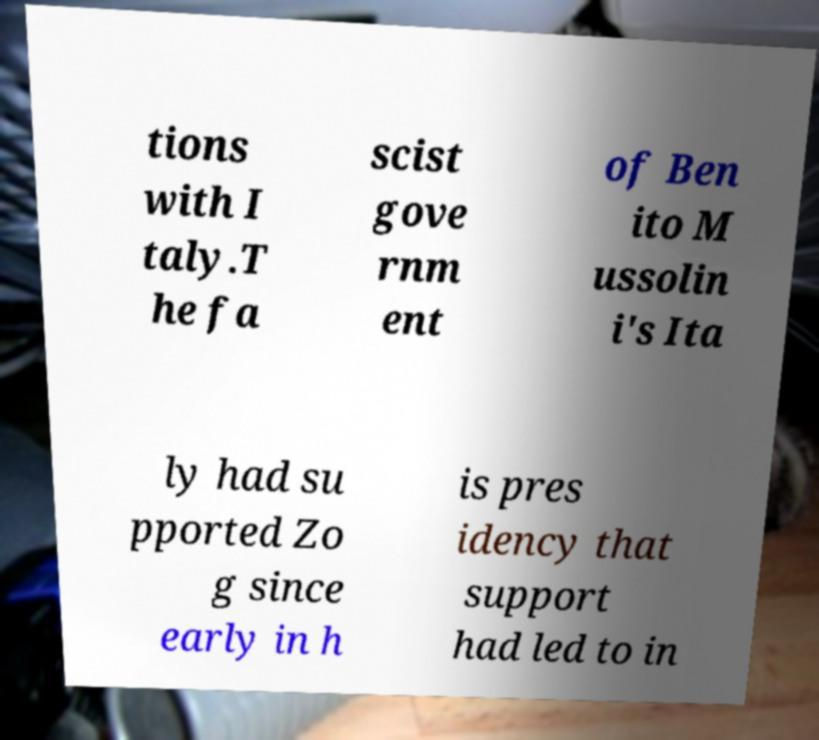Please identify and transcribe the text found in this image. tions with I taly.T he fa scist gove rnm ent of Ben ito M ussolin i's Ita ly had su pported Zo g since early in h is pres idency that support had led to in 